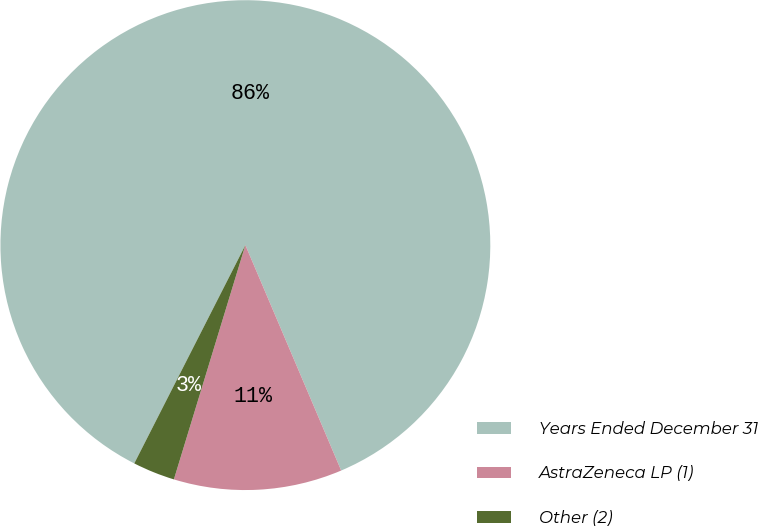Convert chart. <chart><loc_0><loc_0><loc_500><loc_500><pie_chart><fcel>Years Ended December 31<fcel>AstraZeneca LP (1)<fcel>Other (2)<nl><fcel>86.11%<fcel>11.11%<fcel>2.78%<nl></chart> 